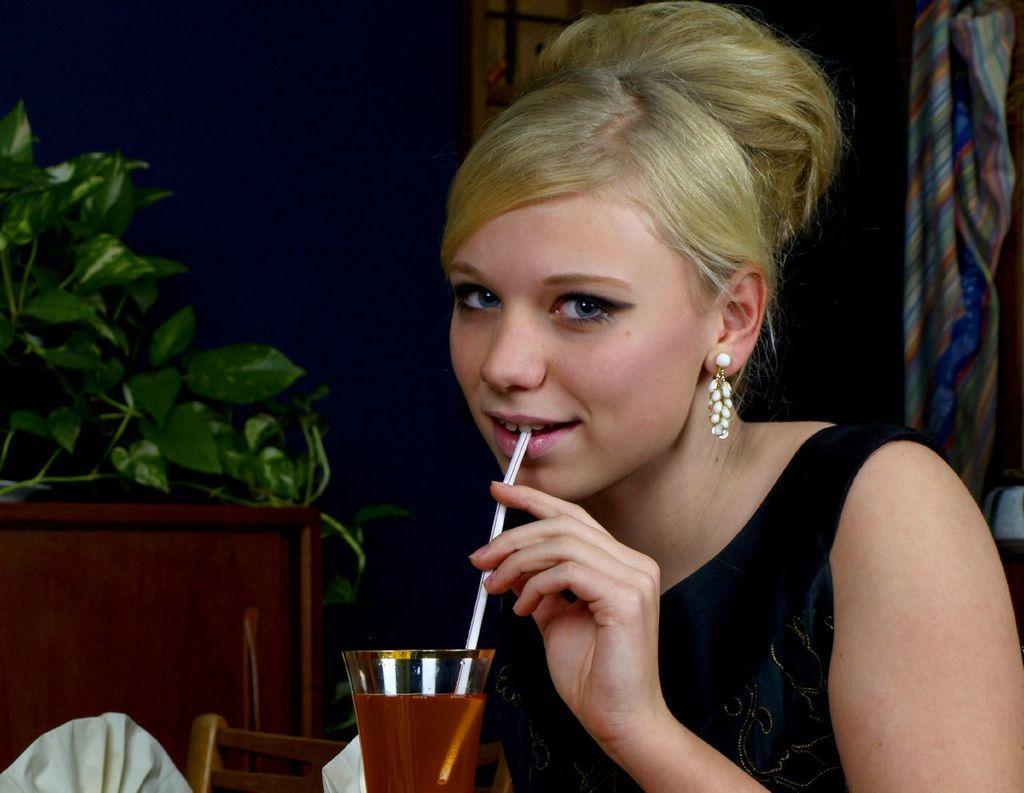Could you give a brief overview of what you see in this image? In this image there is a woman towards the bottom of the image, there is a glass towards the bottom of the image, there is a straw, there are objects towards the bottom of the image, there is a wooden object towards the left of the image, there is a plant towards the left of the image, there is a cloth towards the right of the image, there is an object towards the top of the image, the background of the image is dark. 